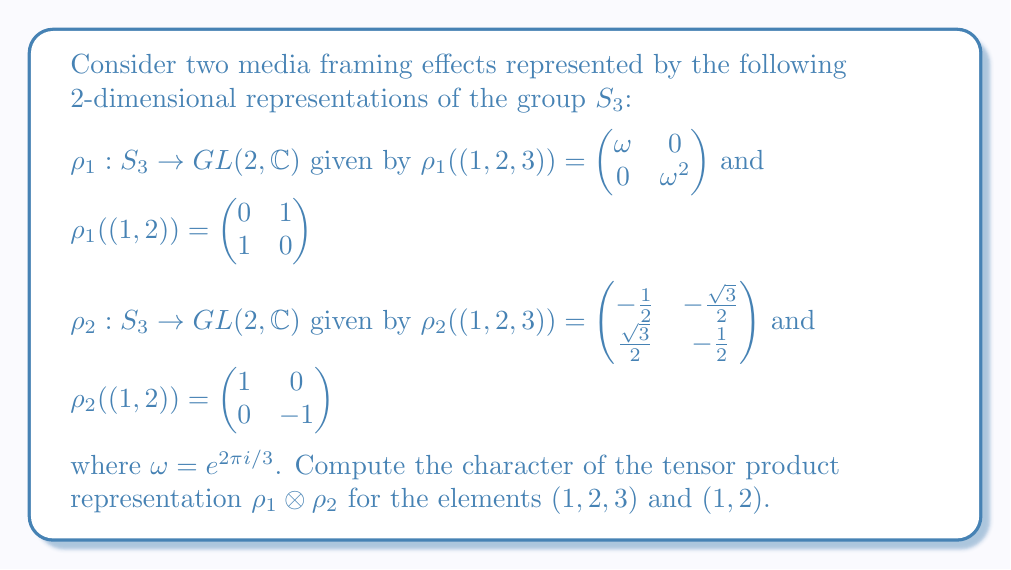Provide a solution to this math problem. To solve this problem, we'll follow these steps:

1) Recall that for two representations $\rho_1$ and $\rho_2$, the character of their tensor product is given by:

   $\chi_{\rho_1 \otimes \rho_2}(g) = \chi_{\rho_1}(g) \cdot \chi_{\rho_2}(g)$

2) First, let's compute the characters for $\rho_1$:
   
   For $(1,2,3)$: $\chi_{\rho_1}((1,2,3)) = \text{Tr}(\rho_1((1,2,3))) = \omega + \omega^2 = -1$
   
   For $(1,2)$: $\chi_{\rho_1}((1,2)) = \text{Tr}(\rho_1((1,2))) = 0 + 0 = 0$

3) Now, let's compute the characters for $\rho_2$:
   
   For $(1,2,3)$: $\chi_{\rho_2}((1,2,3)) = \text{Tr}(\rho_2((1,2,3))) = -\frac{1}{2} - \frac{1}{2} = -1$
   
   For $(1,2)$: $\chi_{\rho_2}((1,2)) = \text{Tr}(\rho_2((1,2))) = 1 + (-1) = 0$

4) Now we can compute the characters of the tensor product:

   For $(1,2,3)$: $\chi_{\rho_1 \otimes \rho_2}((1,2,3)) = \chi_{\rho_1}((1,2,3)) \cdot \chi_{\rho_2}((1,2,3)) = (-1) \cdot (-1) = 1$
   
   For $(1,2)$: $\chi_{\rho_1 \otimes \rho_2}((1,2)) = \chi_{\rho_1}((1,2)) \cdot \chi_{\rho_2}((1,2)) = 0 \cdot 0 = 0$
Answer: $\chi_{\rho_1 \otimes \rho_2}((1,2,3)) = 1$, $\chi_{\rho_1 \otimes \rho_2}((1,2)) = 0$ 